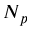<formula> <loc_0><loc_0><loc_500><loc_500>N _ { p }</formula> 